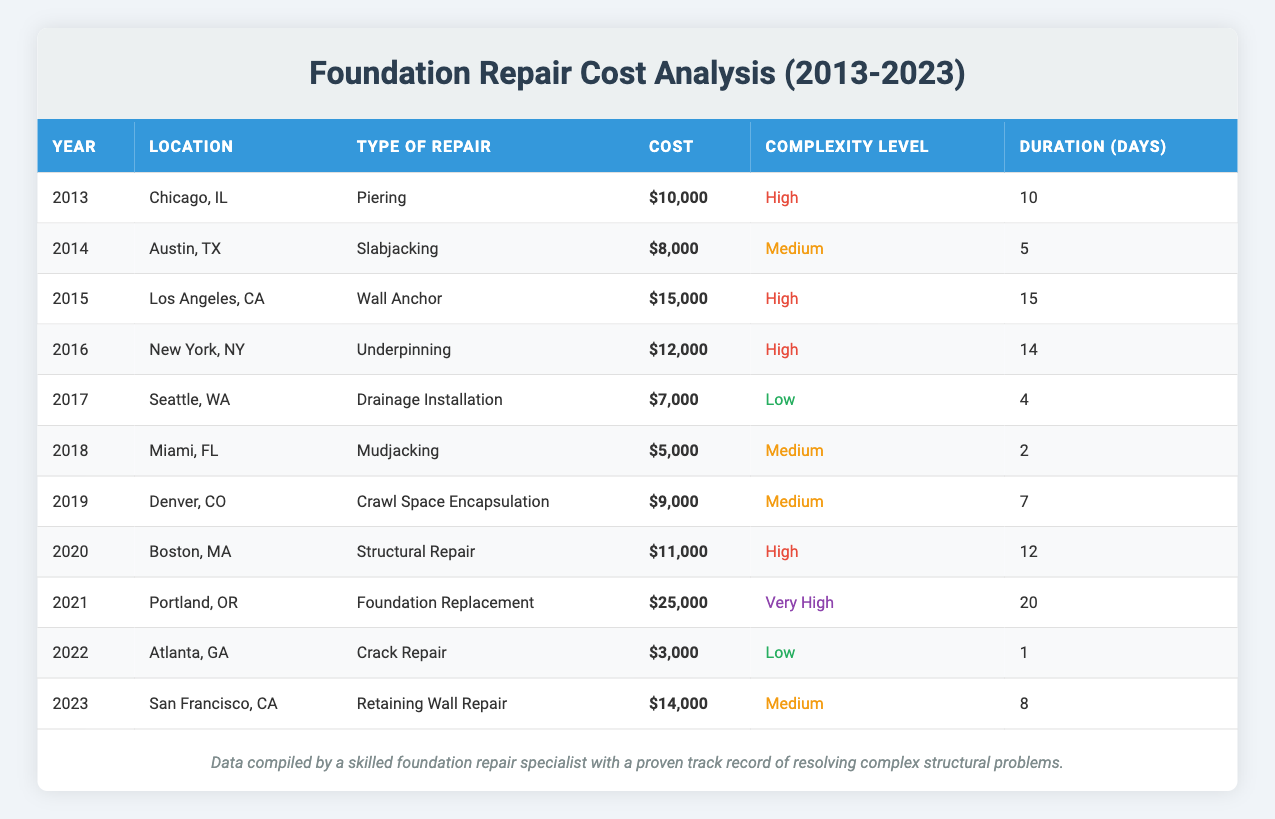What was the total cost of foundation repair projects in 2015? The table shows that in 2015, the project in Los Angeles, CA had a cost of $15,000. Since there is only one project in that year, the total cost for 2015 is $15,000.
Answer: 15000 How many days did the foundation repairs take on average from 2013 to 2023? To find the average duration of all projects, we sum the duration of each project (10 + 5 + 15 + 14 + 4 + 2 + 7 + 12 + 20 + 1 + 8 = 98) and divide it by the number of projects (11), which gives us an average of 98/11 ≈ 8.91 days.
Answer: 8.91 Is the cost of the foundation replacement project in 2021 greater than the cost of all other projects in that year combined? In 2021, the cost of the foundation replacement project was $25,000. There are no other projects recorded that year. Therefore, $25,000 is not only greater than the total cost of other projects combined but also the only cost listed.
Answer: Yes What was the complexity level of the lowest cost repair project? The table indicates that the lowest cost project is the Crack Repair in Atlanta, GA from 2022 costing $3,000. The complexity level for this project is "Low."
Answer: Low Compare the costs of repairs between high and very high complexity levels. In the high complexity category, the costs for projects are $10,000 (2013), $15,000 (2015), $12,000 (2016), $11,000 (2020), totaling $48,000 (for 4 projects). In the very high category, the only cost is $25,000 (2021). So, high complexity repairs cost more in total than very high complexity repairs when compared over the duration surveyed.
Answer: No What is the median cost of foundation repair projects from 2013 to 2023? To find the median, we first list all costs in ascending order: $3,000, $5,000, $7,000, $8,000, $9,000, $10,000, $11,000, $12,000, $14,000, $15,000, and $25,000. Since there are 11 total costs, the median is the 6th value in this order, which is $10,000.
Answer: 10000 Which type of repair had the longest duration, and how long did it take? The longest duration in the table is for the Foundation Replacement in Portland, OR in 2021, which took 20 days.
Answer: 20 days Is the average cost of medium complexity repairs higher than that of low complexity repairs? To compute the averages: Medium complexity repairs have costs of $8,000, $5,000, $9,000, and $14,000 (average 9,000) while low complexity has $7,000 and $3,000 (average 5,000). Thus, medium complexity average is indeed higher.
Answer: Yes What was the cumulative cost of all projects labeled "Medium" complexity? The cumulative costs of medium complexity projects are $8,000 (Slabjacking), $5,000 (Mudjacking), $9,000 (Crawl Space Encapsulation), and $14,000 (Retaining Wall Repair), adding up to a total of $36,000.
Answer: 36000 